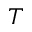Convert formula to latex. <formula><loc_0><loc_0><loc_500><loc_500>T</formula> 